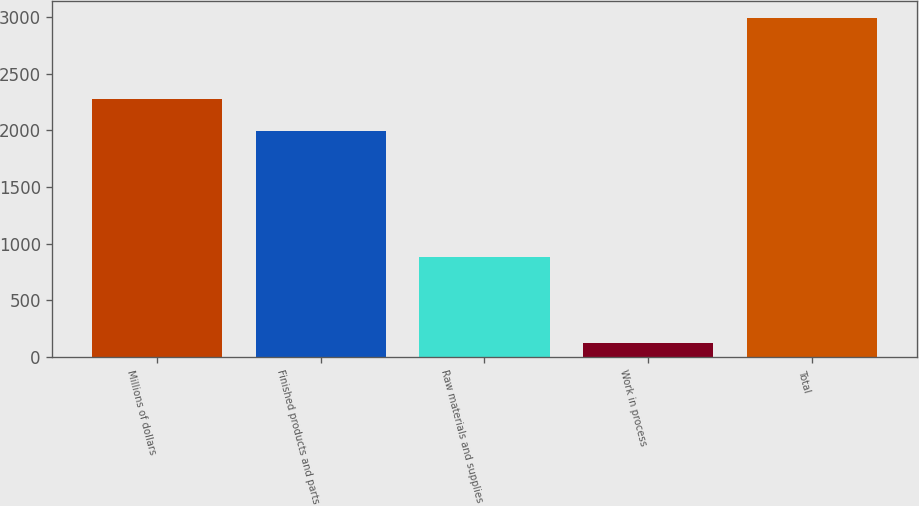Convert chart to OTSL. <chart><loc_0><loc_0><loc_500><loc_500><bar_chart><fcel>Millions of dollars<fcel>Finished products and parts<fcel>Raw materials and supplies<fcel>Work in process<fcel>Total<nl><fcel>2279.1<fcel>1992<fcel>879<fcel>122<fcel>2993<nl></chart> 